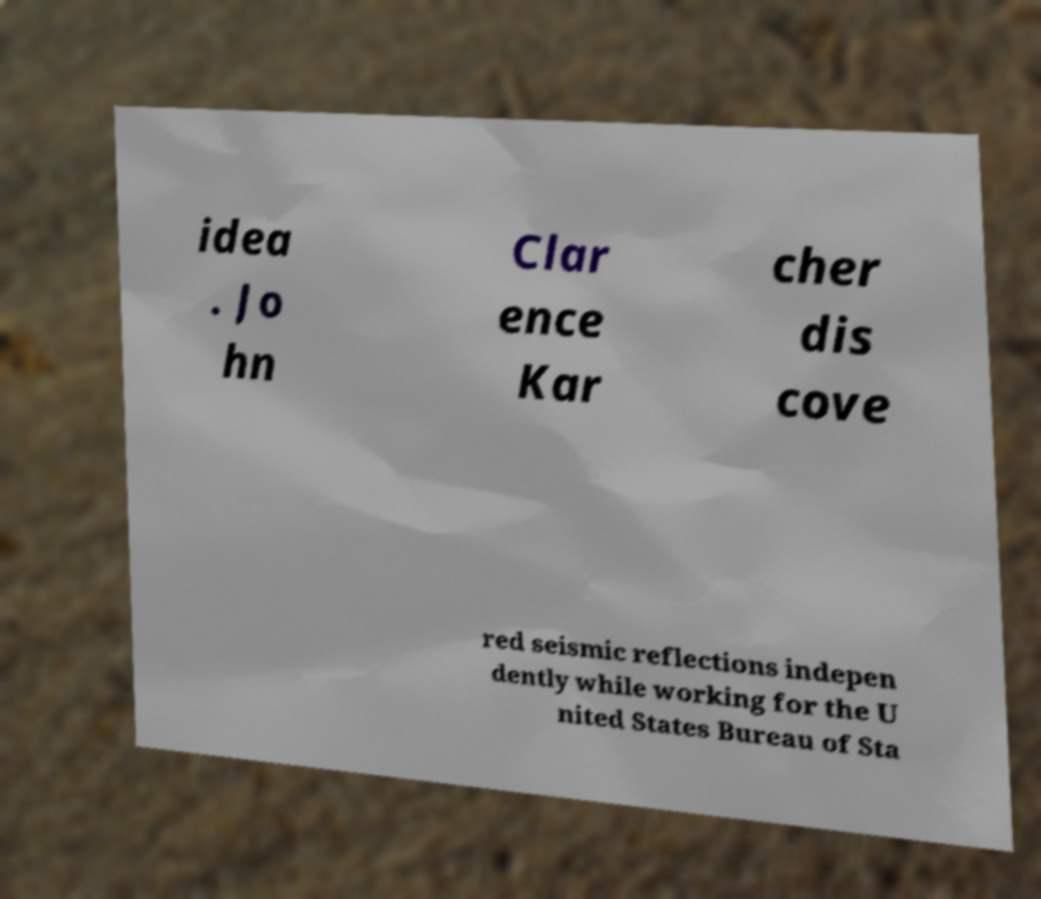What messages or text are displayed in this image? I need them in a readable, typed format. idea . Jo hn Clar ence Kar cher dis cove red seismic reflections indepen dently while working for the U nited States Bureau of Sta 